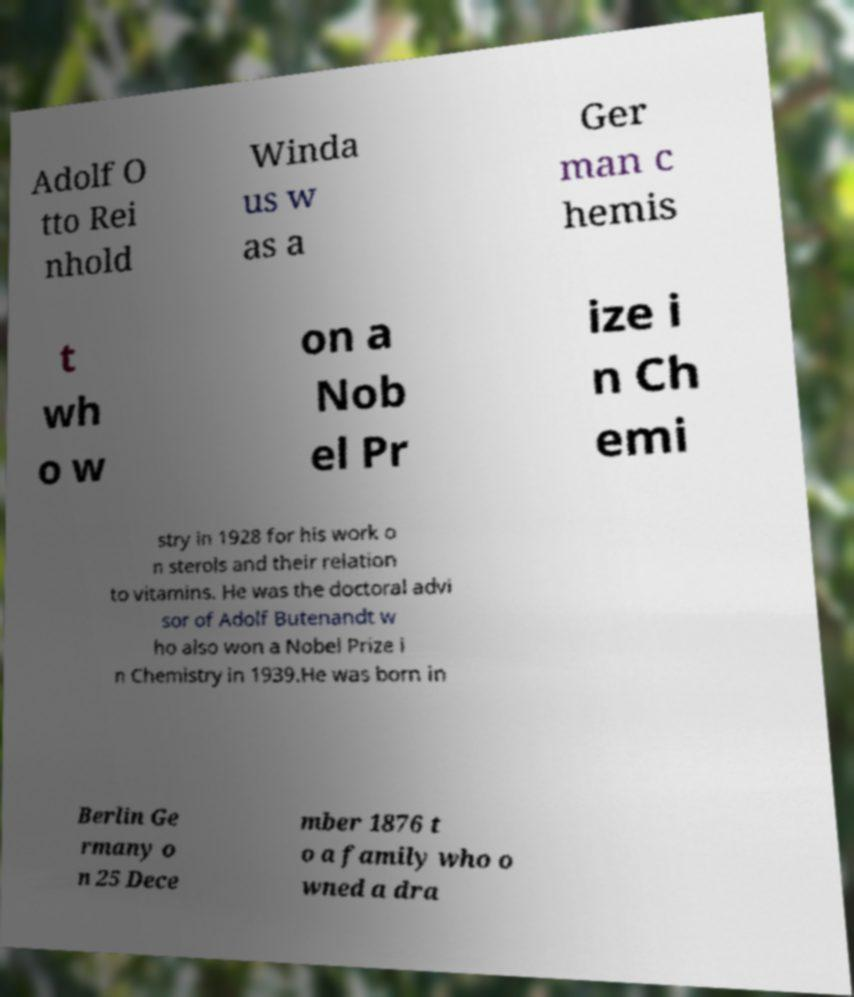For documentation purposes, I need the text within this image transcribed. Could you provide that? Adolf O tto Rei nhold Winda us w as a Ger man c hemis t wh o w on a Nob el Pr ize i n Ch emi stry in 1928 for his work o n sterols and their relation to vitamins. He was the doctoral advi sor of Adolf Butenandt w ho also won a Nobel Prize i n Chemistry in 1939.He was born in Berlin Ge rmany o n 25 Dece mber 1876 t o a family who o wned a dra 